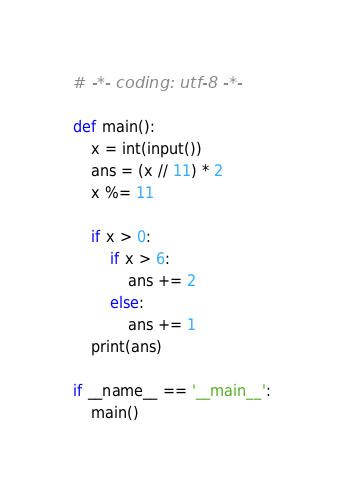<code> <loc_0><loc_0><loc_500><loc_500><_Python_># -*- coding: utf-8 -*-

def main():
    x = int(input())
    ans = (x // 11) * 2
    x %= 11

    if x > 0:
        if x > 6:
            ans += 2
        else:
            ans += 1
    print(ans)

if __name__ == '__main__':
    main()
</code> 